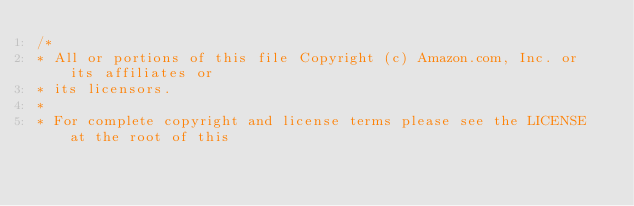<code> <loc_0><loc_0><loc_500><loc_500><_C++_>/*
* All or portions of this file Copyright (c) Amazon.com, Inc. or its affiliates or
* its licensors.
*
* For complete copyright and license terms please see the LICENSE at the root of this</code> 